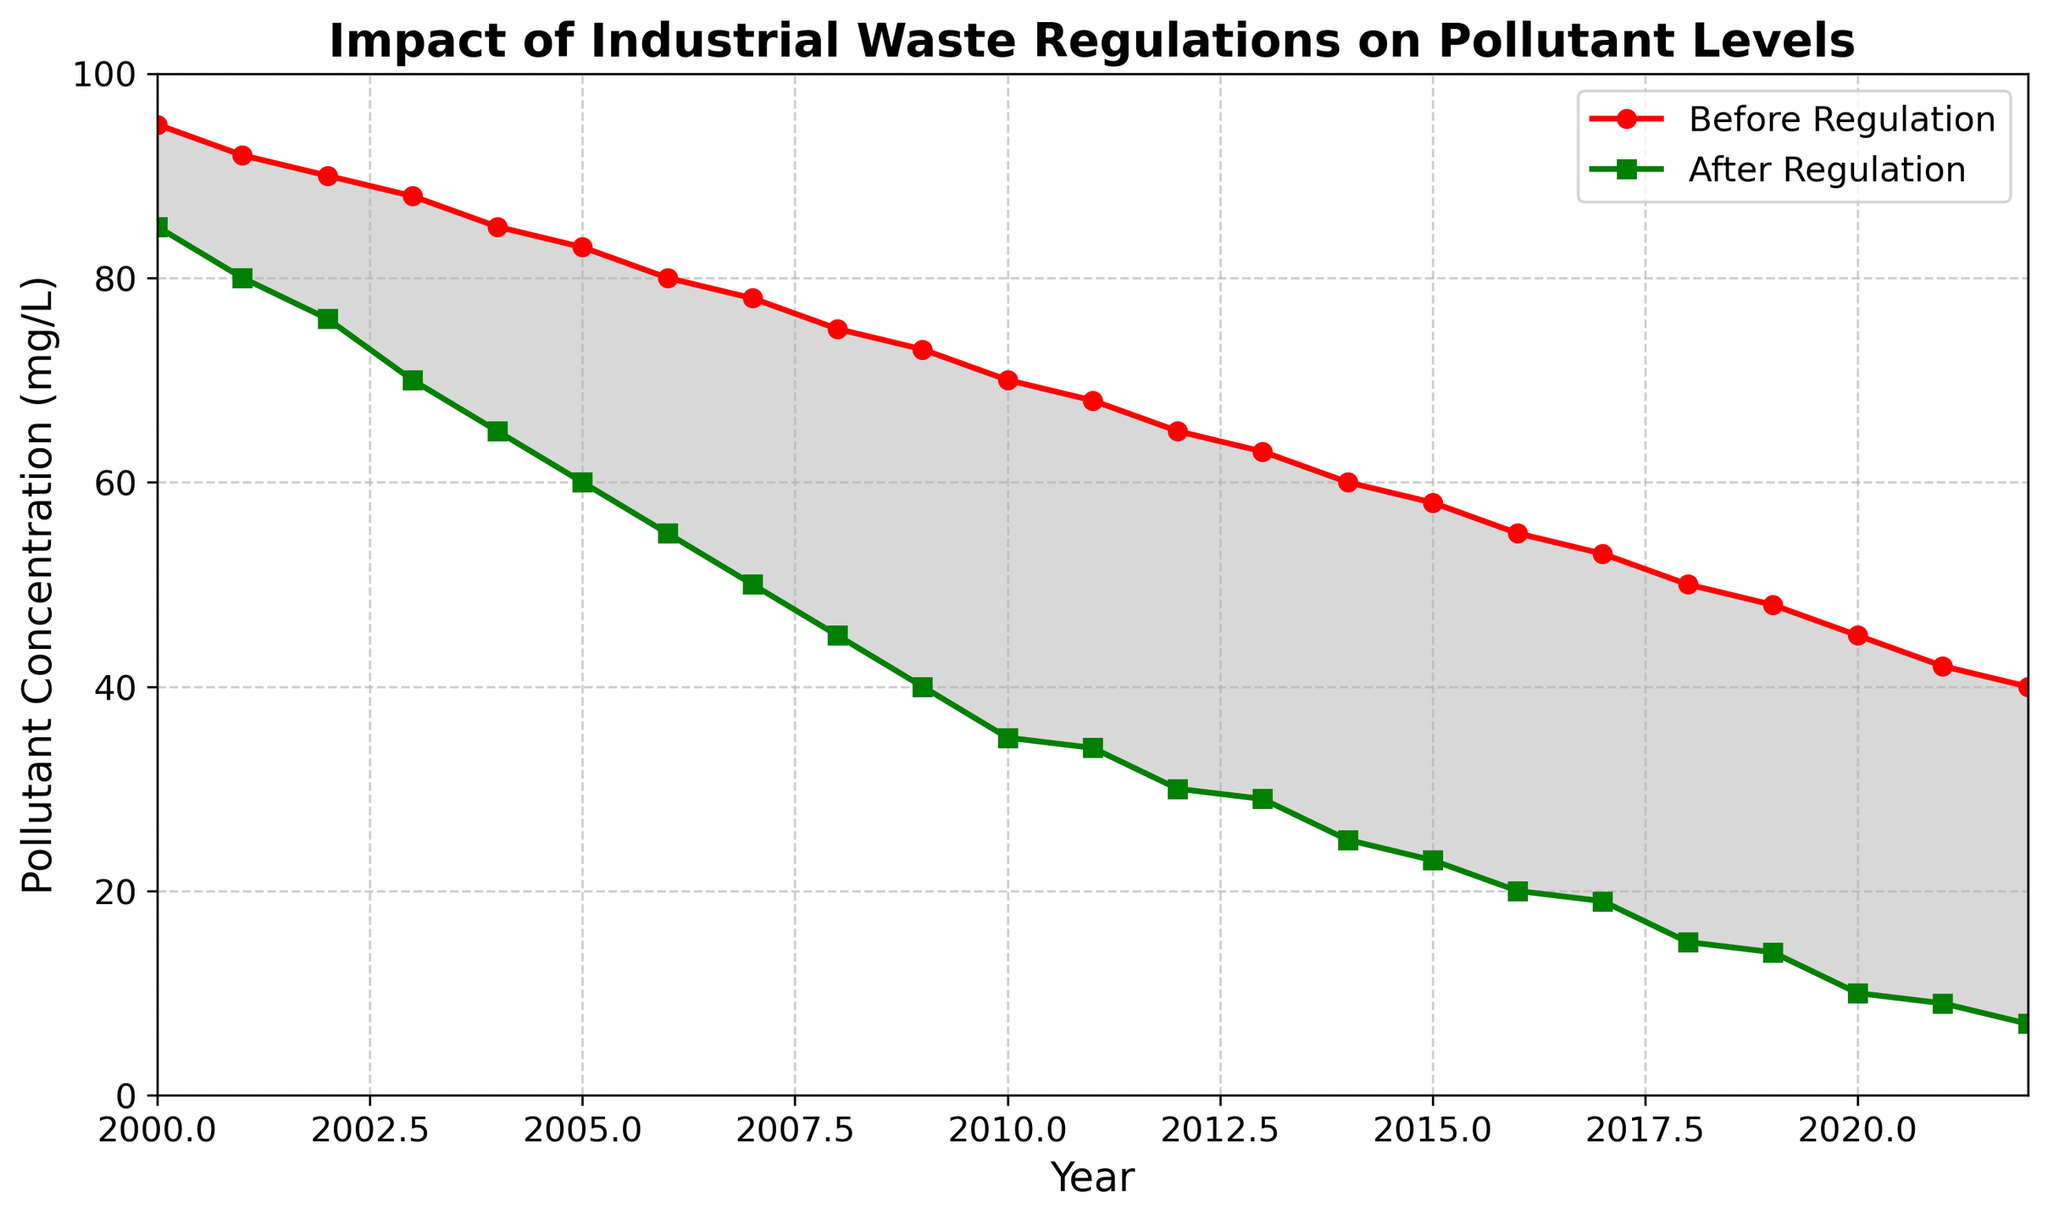What is the difference in pollutant concentration between 2000 and 2010 for 'Before Regulation'? To find the difference, subtract the pollutant concentration in 2010 from that in 2000. The values are 95 (2000) and 70 (2010), so 95 - 70 = 25
Answer: 25 How does the pollutant concentration trend over the years differ before and after regulation? Observe the lines on the plot for 'Before Regulation' and 'After Regulation'. The 'Before Regulation' line shows a gradual decrease, whereas the 'After Regulation' line shows a more rapid decrease
Answer: Gradual decrease before, rapid decrease after In which year does the after regulation pollutant concentration drop below 50 mg/L? Look at the green line for 'After Regulation'; the pollutant concentration drops below 50 mg/L after 2007
Answer: 2007 What is the average pollutant concentration after regulation from 2016 to 2020? Add the pollutant concentrations for the years 2016 to 2020 and divide by the number of years: (20 + 19 + 15 + 14 + 10) / 5 = 78 / 5
Answer: 15.6 Compare the pollutant concentration in the year 2020 before and after regulation. Which is higher? Check the values for the year 2020 on both lines. Before regulation, it is 45, and after regulation, it is 10. Therefore, before regulation is higher
Answer: Before regulation Does the difference between 'Before Regulation' and 'After Regulation' increase or decrease over time? Observe the shaded area between the two lines. The shaded area gets larger over time indicating the difference increases
Answer: Increases What is the pollutant concentration reduction from 2000 to 2022 for 'After Regulation'? Subtract the pollutant concentration in 2022 from that in 2000. The values are 85 (2000) and 7 (2022), so 85 - 7 = 78
Answer: 78 By what percentage did the pollutant concentration decrease from 2000 to 2022 for 'Full Regulation'? First find the reduction: 85 (2000) - 7 (2022) = 78. Next, calculate the percentage: (78 / 85) * 100 = 91.76%
Answer: 91.76% Is there a year when both before and after regulation concentrations are equal? Compare both lines; they never touch, so there is no year where the concentrations are equal
Answer: No 